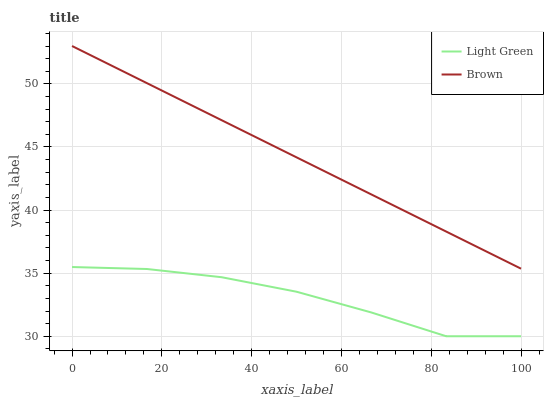Does Light Green have the minimum area under the curve?
Answer yes or no. Yes. Does Brown have the maximum area under the curve?
Answer yes or no. Yes. Does Light Green have the maximum area under the curve?
Answer yes or no. No. Is Brown the smoothest?
Answer yes or no. Yes. Is Light Green the roughest?
Answer yes or no. Yes. Is Light Green the smoothest?
Answer yes or no. No. Does Light Green have the lowest value?
Answer yes or no. Yes. Does Brown have the highest value?
Answer yes or no. Yes. Does Light Green have the highest value?
Answer yes or no. No. Is Light Green less than Brown?
Answer yes or no. Yes. Is Brown greater than Light Green?
Answer yes or no. Yes. Does Light Green intersect Brown?
Answer yes or no. No. 